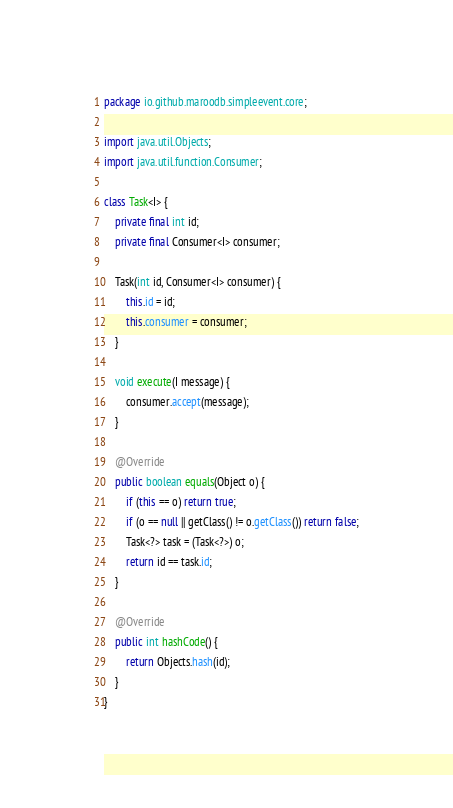<code> <loc_0><loc_0><loc_500><loc_500><_Java_>package io.github.maroodb.simpleevent.core;

import java.util.Objects;
import java.util.function.Consumer;

class Task<I> {
    private final int id;
    private final Consumer<I> consumer;

    Task(int id, Consumer<I> consumer) {
        this.id = id;
        this.consumer = consumer;
    }

    void execute(I message) {
        consumer.accept(message);
    }

    @Override
    public boolean equals(Object o) {
        if (this == o) return true;
        if (o == null || getClass() != o.getClass()) return false;
        Task<?> task = (Task<?>) o;
        return id == task.id;
    }

    @Override
    public int hashCode() {
        return Objects.hash(id);
    }
}
</code> 